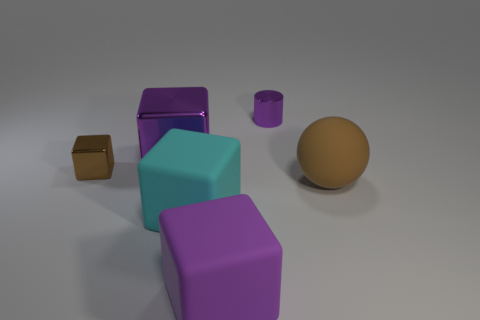Subtract 1 blocks. How many blocks are left? 3 Subtract all gray blocks. Subtract all purple spheres. How many blocks are left? 4 Add 2 big gray metallic balls. How many objects exist? 8 Subtract all blocks. How many objects are left? 2 Add 5 small cyan rubber cubes. How many small cyan rubber cubes exist? 5 Subtract 0 gray blocks. How many objects are left? 6 Subtract all purple rubber cubes. Subtract all small metallic cylinders. How many objects are left? 4 Add 1 big cyan blocks. How many big cyan blocks are left? 2 